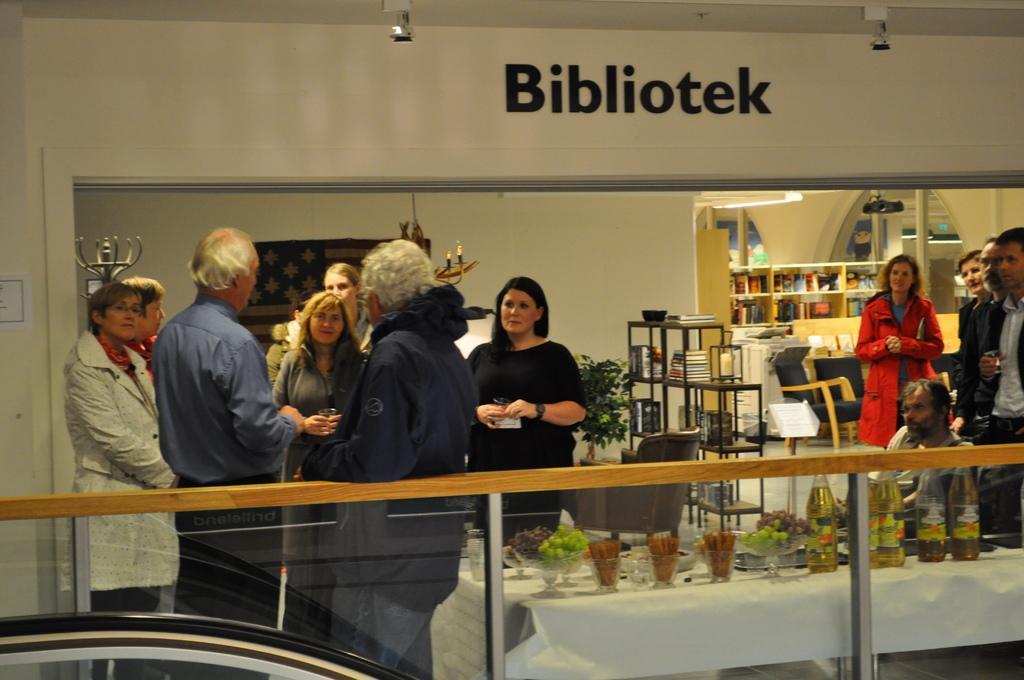Could you give a brief overview of what you see in this image? In this picture we can see some people are standing and a person is sitting and in front of the people there is a table and on the table there are bottles, bowls, glass, fruits and other things. Behind the people there is a houseplant, books and other objects in the racks and shelves. At the top there is a name board on the wall, chandelier and other things. 